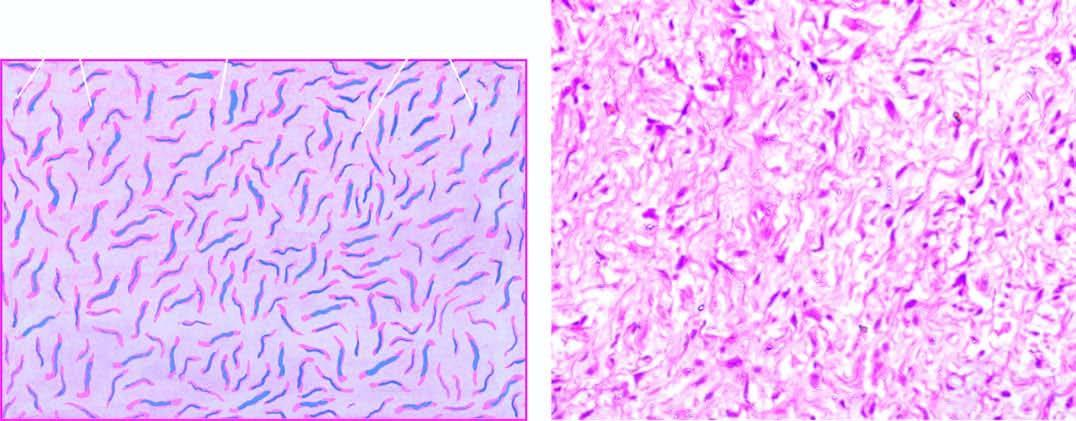s a residual nerve fibre also identified?
Answer the question using a single word or phrase. No 